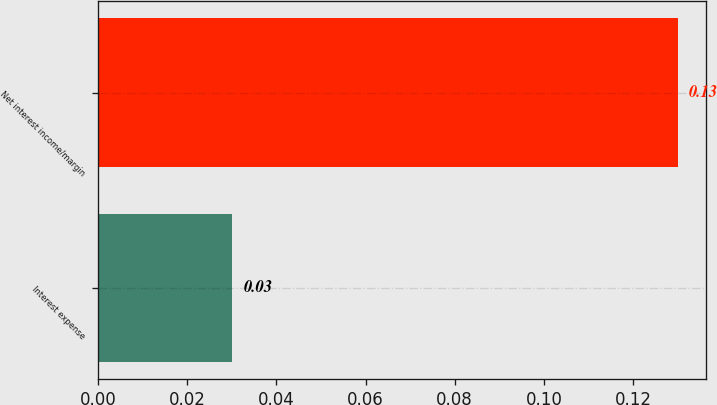<chart> <loc_0><loc_0><loc_500><loc_500><bar_chart><fcel>Interest expense<fcel>Net interest income/margin<nl><fcel>0.03<fcel>0.13<nl></chart> 